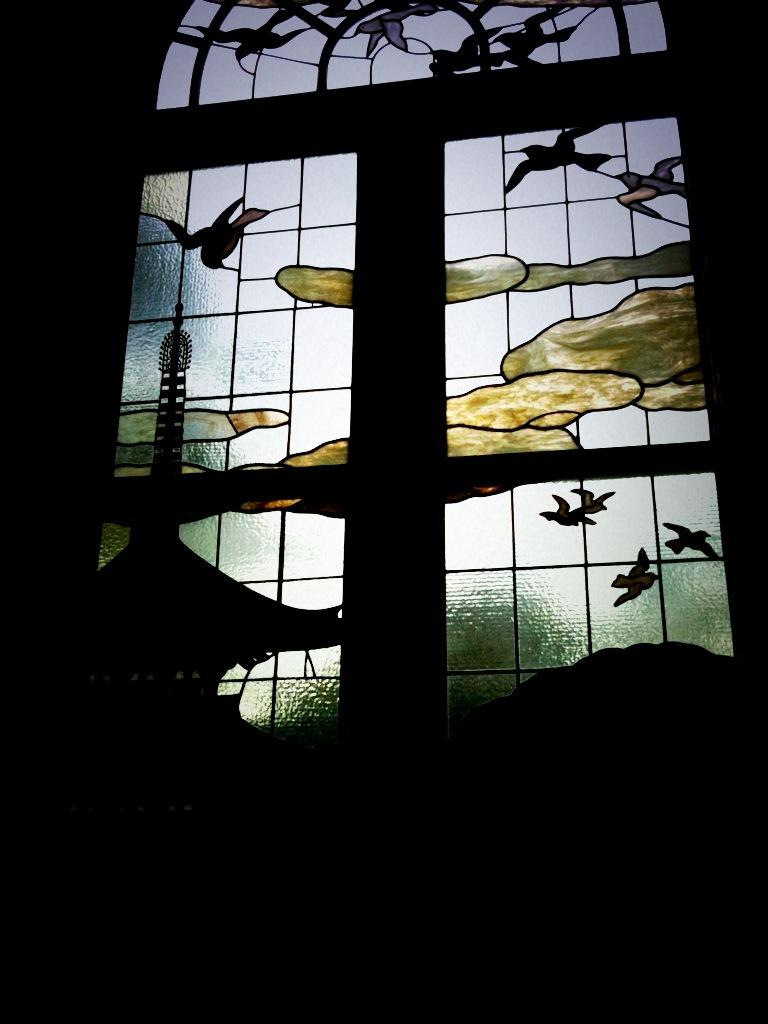What type of window is featured in the image? There is a designer glass window in the picture. What can be observed about the background of the image? The background of the image is dark. How many girls are present in the image? There is no mention of girls in the image, as the facts only describe a designer glass window and a dark background. 